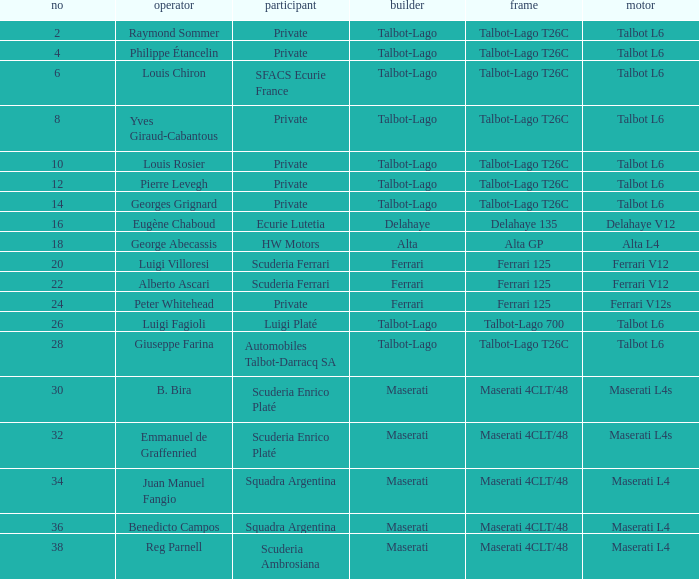Name the engine for ecurie lutetia Delahaye V12. 